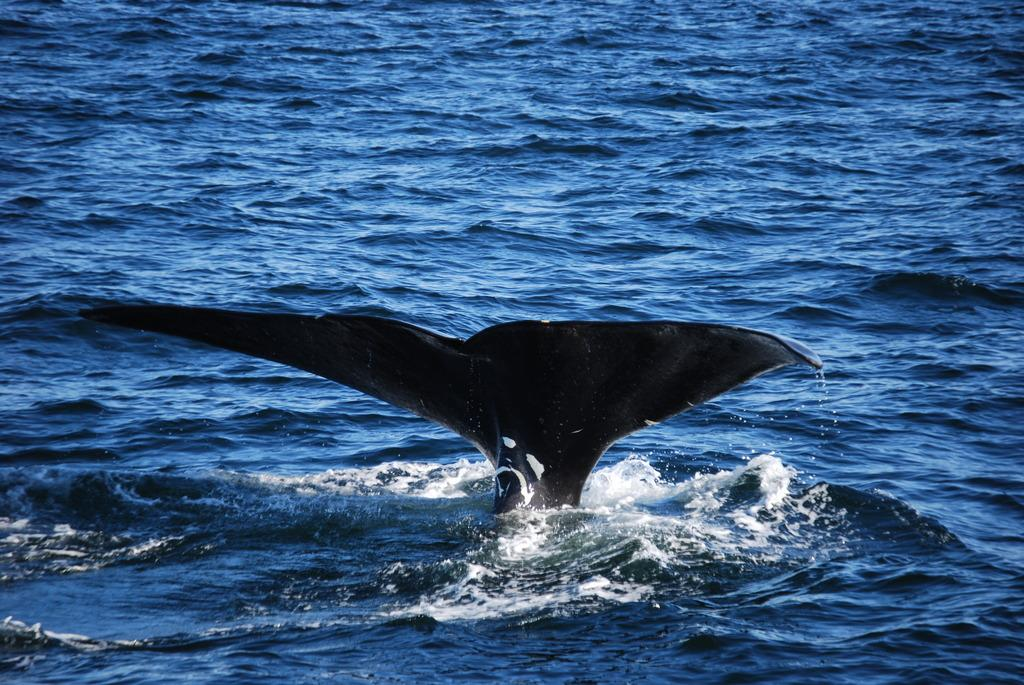What is the main subject of the picture? The main subject of the picture is a fishtail. What color is the fishtail? The fishtail is black in color. What is the setting of the picture? The picture contains water. What color is the water? The water is blue in color. Can you see a rabbit asking for help in the picture? No, there is no rabbit or any indication of help being asked for in the picture. The image only features a black fishtail in blue water. 